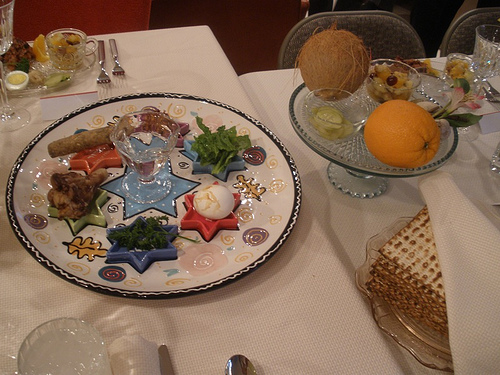Please provide a short description for this region: [0.57, 0.29, 0.92, 0.52]. The region [0.57, 0.29, 0.92, 0.52] contains a clear glass cake plate, which has an orange placed on top of it. This provides a colorful and appealing display. 